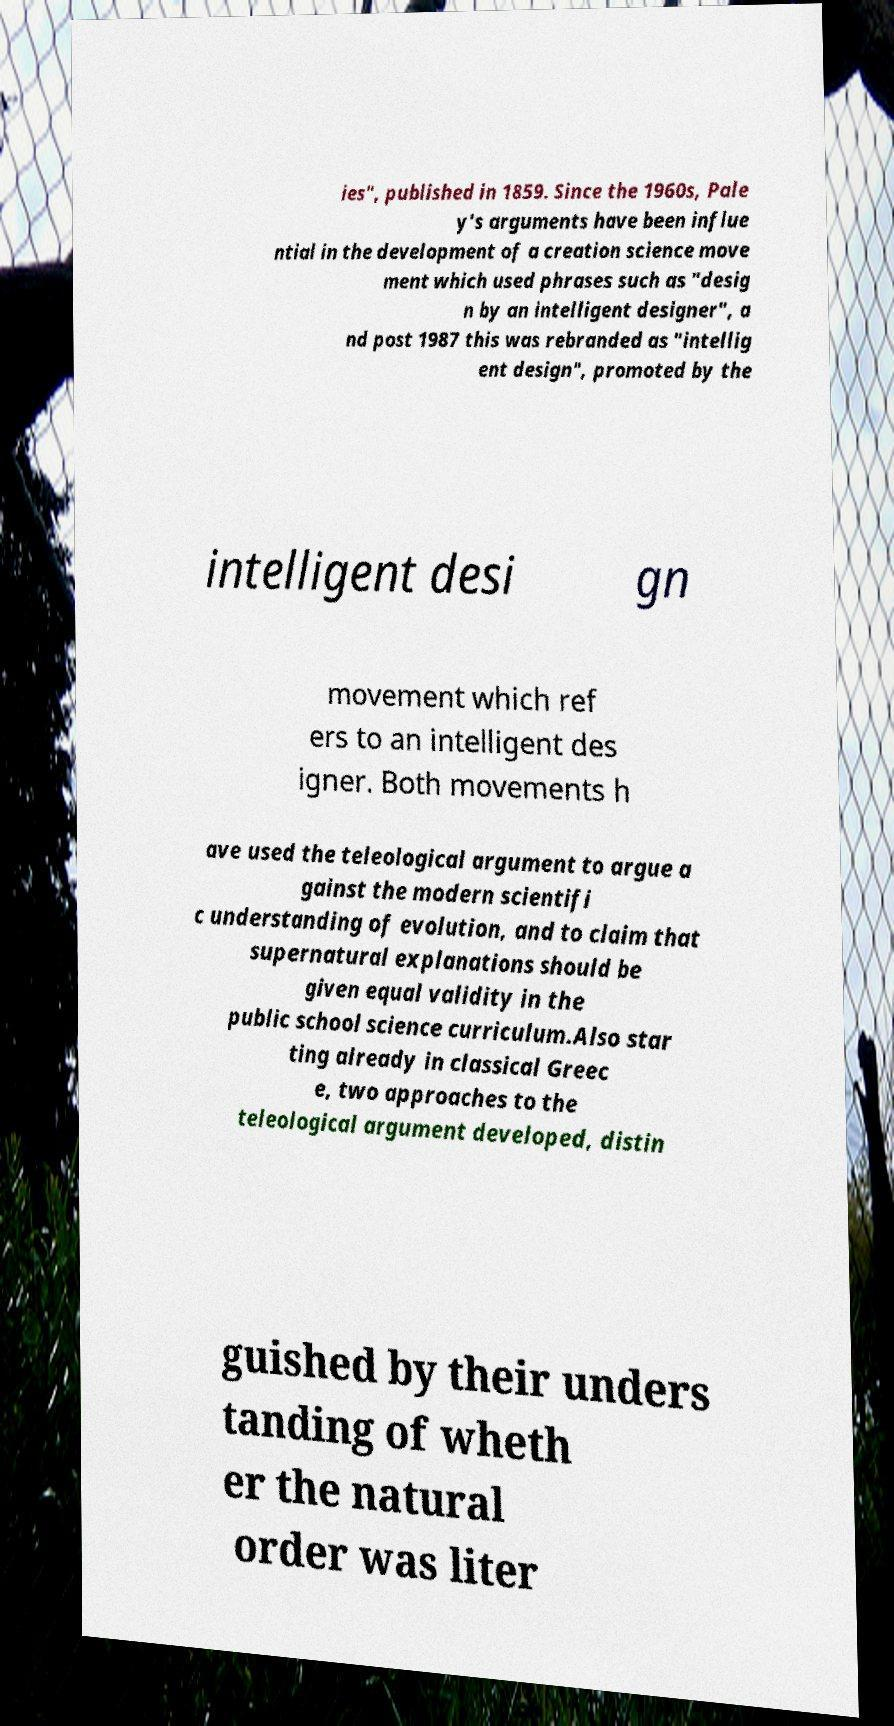There's text embedded in this image that I need extracted. Can you transcribe it verbatim? ies", published in 1859. Since the 1960s, Pale y's arguments have been influe ntial in the development of a creation science move ment which used phrases such as "desig n by an intelligent designer", a nd post 1987 this was rebranded as "intellig ent design", promoted by the intelligent desi gn movement which ref ers to an intelligent des igner. Both movements h ave used the teleological argument to argue a gainst the modern scientifi c understanding of evolution, and to claim that supernatural explanations should be given equal validity in the public school science curriculum.Also star ting already in classical Greec e, two approaches to the teleological argument developed, distin guished by their unders tanding of wheth er the natural order was liter 